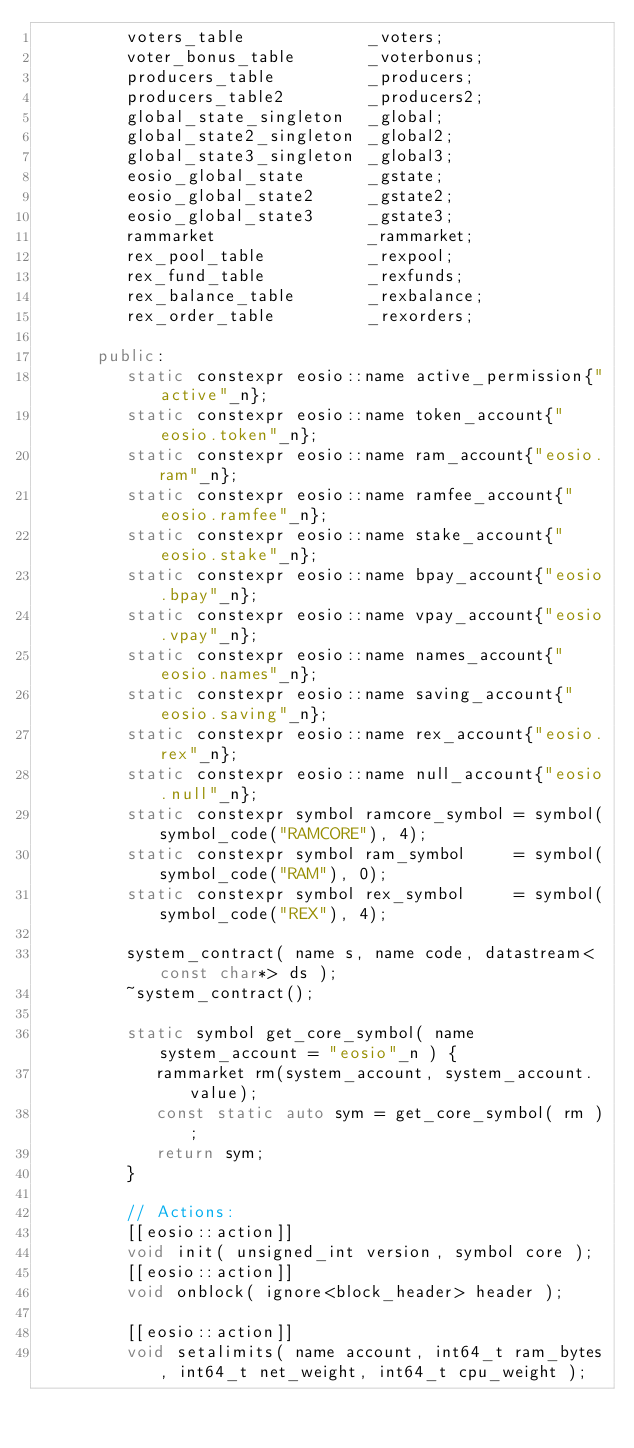Convert code to text. <code><loc_0><loc_0><loc_500><loc_500><_C++_>         voters_table            _voters;
         voter_bonus_table       _voterbonus;
         producers_table         _producers;
         producers_table2        _producers2;
         global_state_singleton  _global;
         global_state2_singleton _global2;
         global_state3_singleton _global3;
         eosio_global_state      _gstate;
         eosio_global_state2     _gstate2;
         eosio_global_state3     _gstate3;
         rammarket               _rammarket;
         rex_pool_table          _rexpool;
         rex_fund_table          _rexfunds;
         rex_balance_table       _rexbalance;
         rex_order_table         _rexorders;

      public:
         static constexpr eosio::name active_permission{"active"_n};
         static constexpr eosio::name token_account{"eosio.token"_n};
         static constexpr eosio::name ram_account{"eosio.ram"_n};
         static constexpr eosio::name ramfee_account{"eosio.ramfee"_n};
         static constexpr eosio::name stake_account{"eosio.stake"_n};
         static constexpr eosio::name bpay_account{"eosio.bpay"_n};
         static constexpr eosio::name vpay_account{"eosio.vpay"_n};
         static constexpr eosio::name names_account{"eosio.names"_n};
         static constexpr eosio::name saving_account{"eosio.saving"_n};
         static constexpr eosio::name rex_account{"eosio.rex"_n};
         static constexpr eosio::name null_account{"eosio.null"_n};
         static constexpr symbol ramcore_symbol = symbol(symbol_code("RAMCORE"), 4);
         static constexpr symbol ram_symbol     = symbol(symbol_code("RAM"), 0);
         static constexpr symbol rex_symbol     = symbol(symbol_code("REX"), 4);

         system_contract( name s, name code, datastream<const char*> ds );
         ~system_contract();

         static symbol get_core_symbol( name system_account = "eosio"_n ) {
            rammarket rm(system_account, system_account.value);
            const static auto sym = get_core_symbol( rm );
            return sym;
         }

         // Actions:
         [[eosio::action]]
         void init( unsigned_int version, symbol core );
         [[eosio::action]]
         void onblock( ignore<block_header> header );

         [[eosio::action]]
         void setalimits( name account, int64_t ram_bytes, int64_t net_weight, int64_t cpu_weight );
</code> 